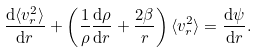Convert formula to latex. <formula><loc_0><loc_0><loc_500><loc_500>\frac { \mathrm d \langle v _ { r } ^ { 2 } \rangle } { \mathrm d r } + \left ( \frac { 1 } { \rho } \frac { \mathrm d \rho } { \mathrm d r } + \frac { 2 \beta } { r } \right ) \langle v _ { r } ^ { 2 } \rangle = \frac { \mathrm d \psi } { \mathrm d r } .</formula> 